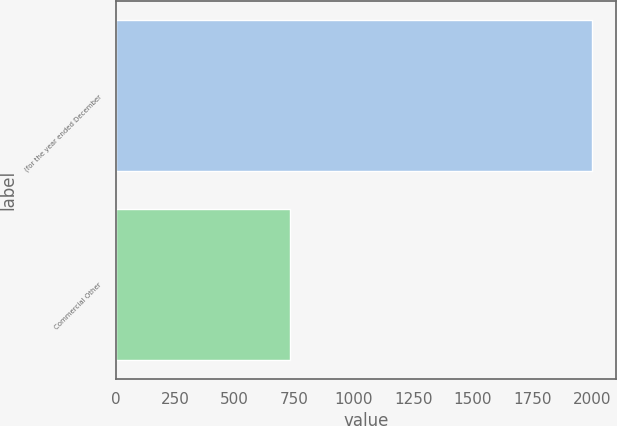Convert chart. <chart><loc_0><loc_0><loc_500><loc_500><bar_chart><fcel>(for the year ended December<fcel>Commercial Other<nl><fcel>2003<fcel>733<nl></chart> 